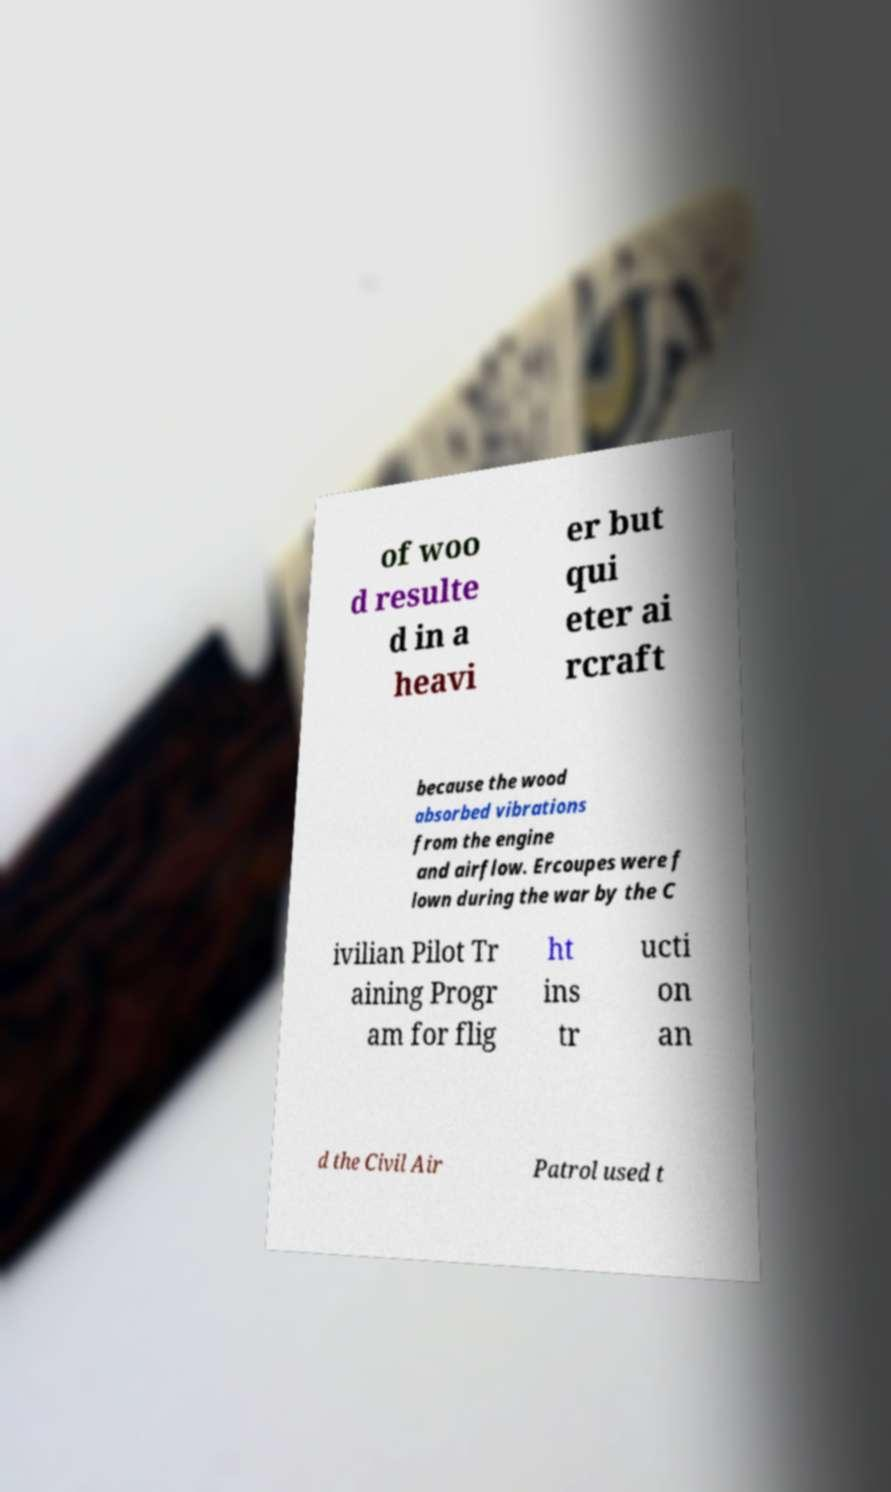I need the written content from this picture converted into text. Can you do that? of woo d resulte d in a heavi er but qui eter ai rcraft because the wood absorbed vibrations from the engine and airflow. Ercoupes were f lown during the war by the C ivilian Pilot Tr aining Progr am for flig ht ins tr ucti on an d the Civil Air Patrol used t 